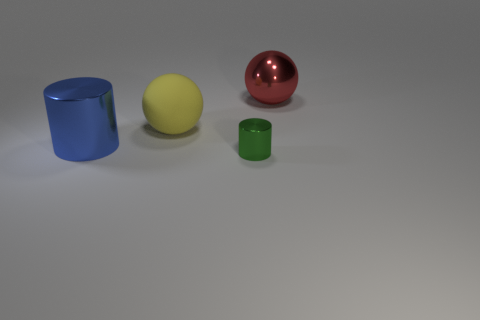Subtract all blue cylinders. How many cylinders are left? 1 Subtract 1 balls. How many balls are left? 1 Add 1 cylinders. How many objects exist? 5 Subtract all green cylinders. How many red spheres are left? 1 Subtract all green blocks. Subtract all small metal cylinders. How many objects are left? 3 Add 4 large yellow objects. How many large yellow objects are left? 5 Add 3 small purple rubber cubes. How many small purple rubber cubes exist? 3 Subtract 0 red cylinders. How many objects are left? 4 Subtract all gray balls. Subtract all blue blocks. How many balls are left? 2 